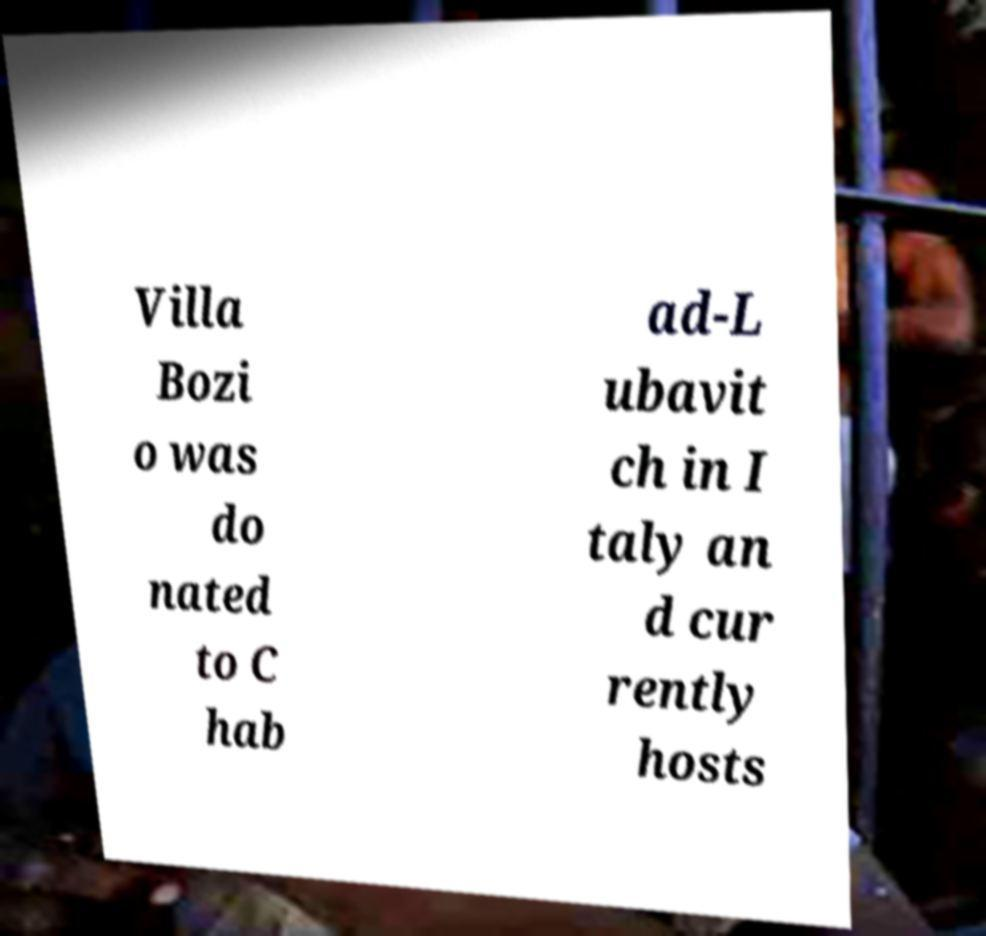Could you extract and type out the text from this image? Villa Bozi o was do nated to C hab ad-L ubavit ch in I taly an d cur rently hosts 